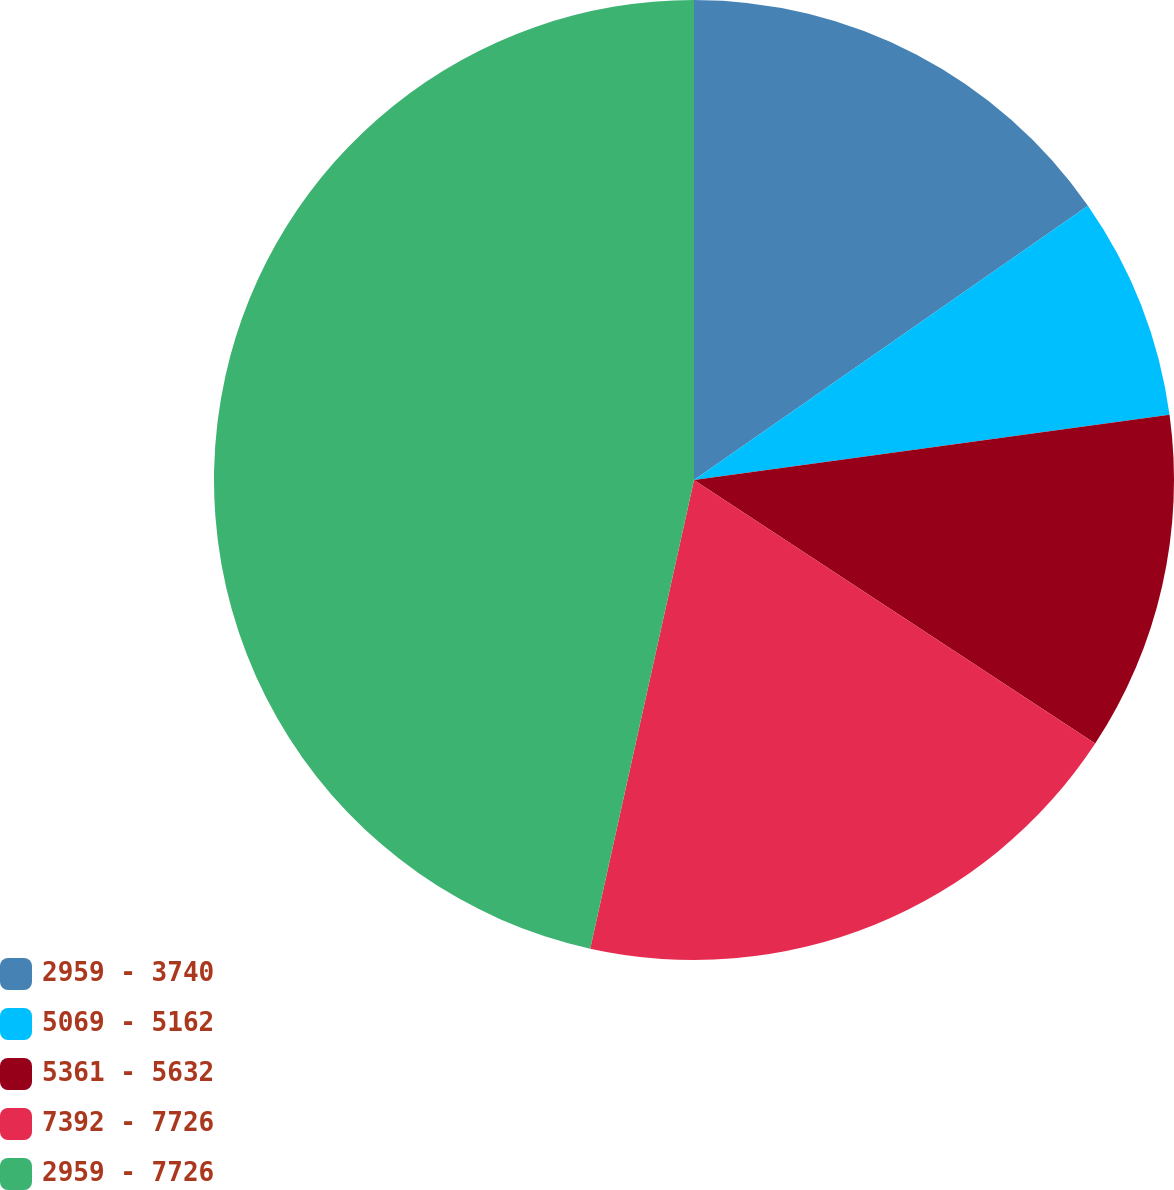<chart> <loc_0><loc_0><loc_500><loc_500><pie_chart><fcel>2959 - 3740<fcel>5069 - 5162<fcel>5361 - 5632<fcel>7392 - 7726<fcel>2959 - 7726<nl><fcel>15.32%<fcel>7.51%<fcel>11.42%<fcel>19.22%<fcel>46.53%<nl></chart> 